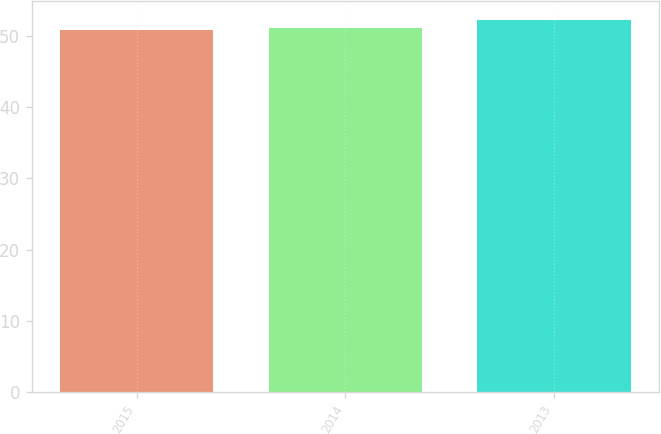Convert chart to OTSL. <chart><loc_0><loc_0><loc_500><loc_500><bar_chart><fcel>2015<fcel>2014<fcel>2013<nl><fcel>50.8<fcel>51.2<fcel>52.3<nl></chart> 